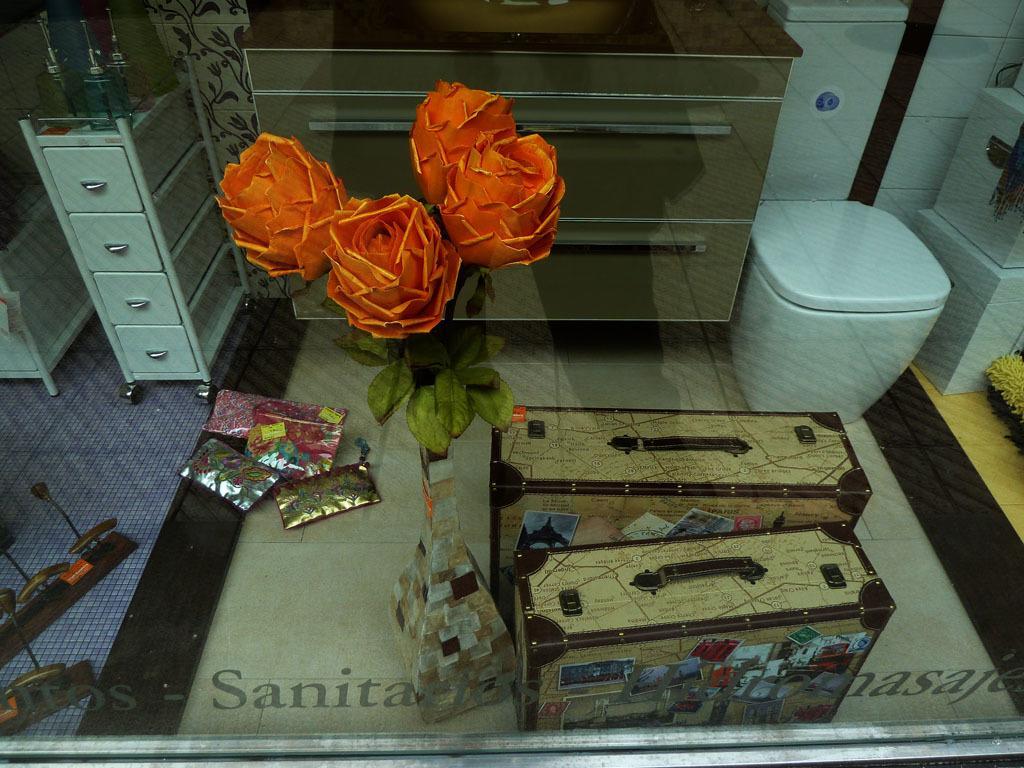Describe this image in one or two sentences. In the picture we can see a floor with two boxes and one white color box near the wall and beside it we can see desk with sink and beside it we can see another desk on it we can see some things are placed and we can see an artificial plant with flowers and some gift packs on the floor. 